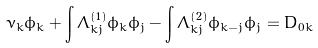<formula> <loc_0><loc_0><loc_500><loc_500>\nu _ { k } \phi _ { k } + \int \Lambda _ { k j } ^ { \left ( 1 \right ) } \phi _ { k } \phi _ { j } - \int \Lambda _ { k j } ^ { \left ( 2 \right ) } \phi _ { k - j } \phi _ { j } = D _ { 0 k }</formula> 